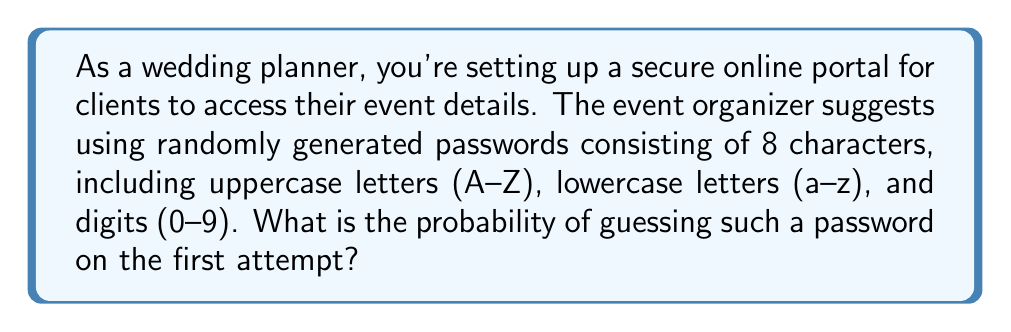Help me with this question. To solve this problem, we need to follow these steps:

1. Determine the total number of possible characters:
   - 26 uppercase letters
   - 26 lowercase letters
   - 10 digits
   Total: 26 + 26 + 10 = 62 possible characters

2. Calculate the number of possible passwords:
   Since each of the 8 characters can be any of the 62 possible characters, we use the multiplication principle.
   
   Number of possible passwords = $62^8$

3. Calculate the probability of guessing the correct password on the first attempt:
   Probability = $\frac{1}{\text{Number of possible passwords}}$

   $P(\text{correct guess}) = \frac{1}{62^8}$

4. Simplify the fraction:
   $P(\text{correct guess}) = \frac{1}{218,340,105,584,896}$

This probability is extremely small, approximately $4.58 \times 10^{-15}$, which demonstrates the security of using such a password system for the wedding planning portal.
Answer: $\frac{1}{62^8}$ or $\frac{1}{218,340,105,584,896}$ 